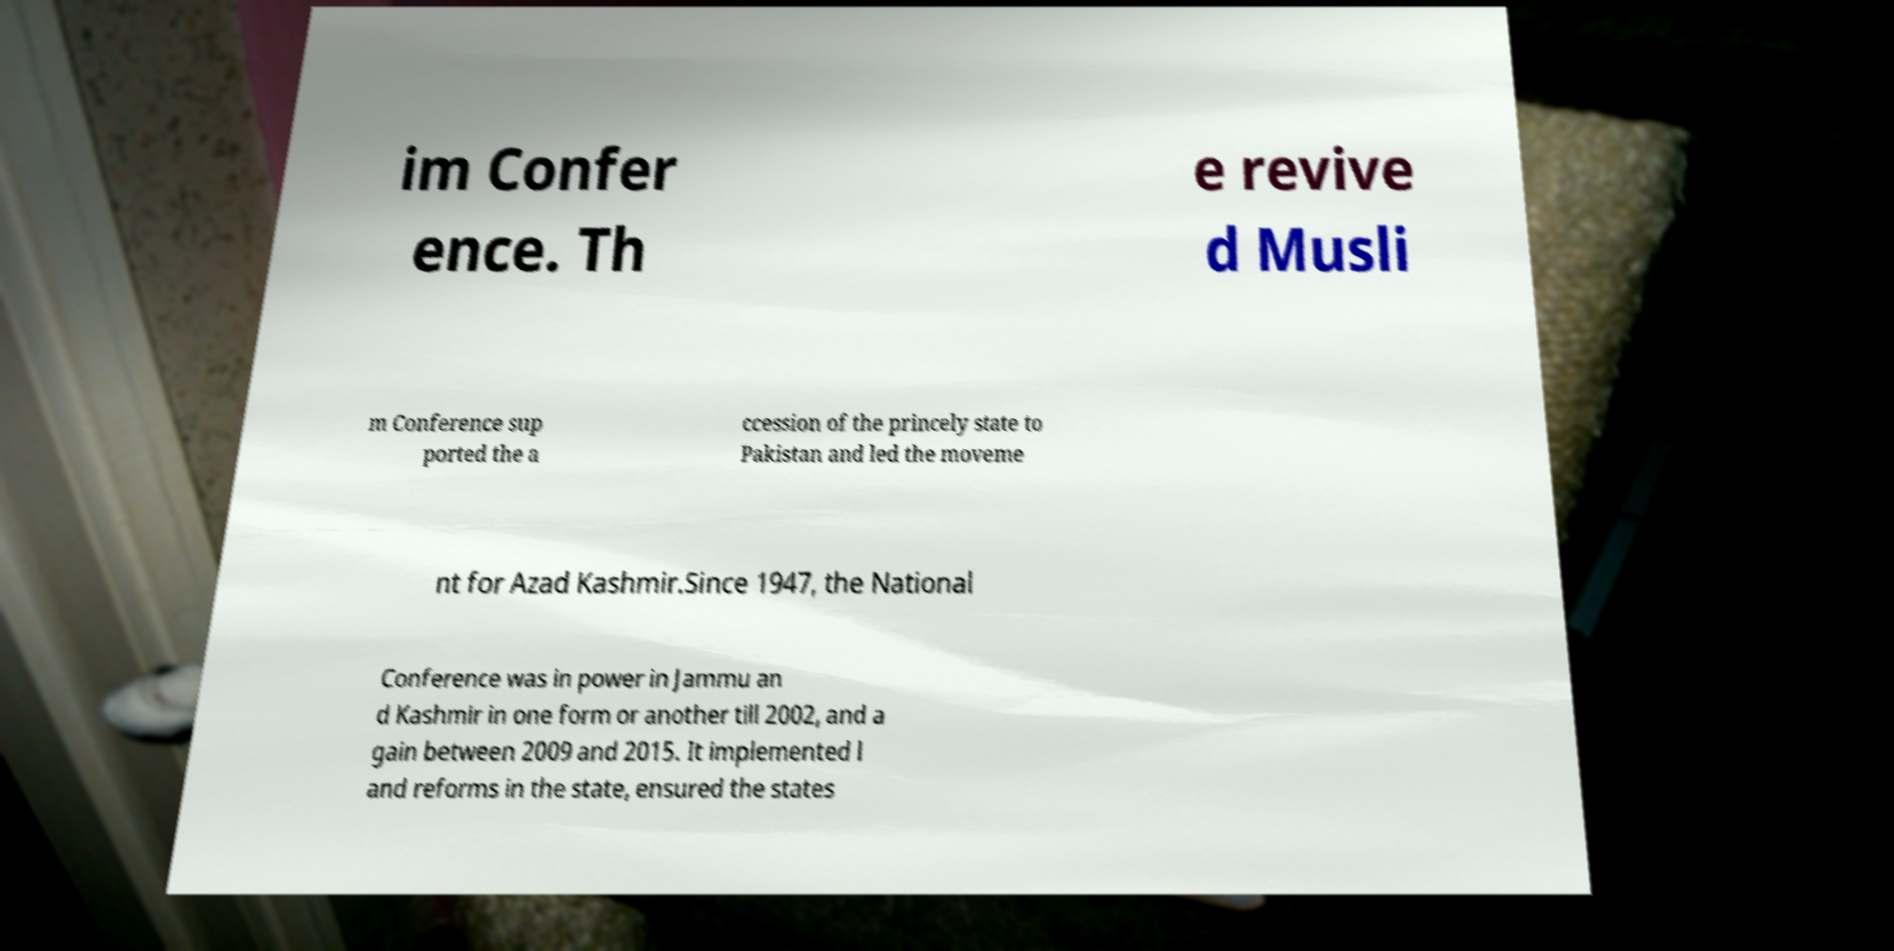There's text embedded in this image that I need extracted. Can you transcribe it verbatim? im Confer ence. Th e revive d Musli m Conference sup ported the a ccession of the princely state to Pakistan and led the moveme nt for Azad Kashmir.Since 1947, the National Conference was in power in Jammu an d Kashmir in one form or another till 2002, and a gain between 2009 and 2015. It implemented l and reforms in the state, ensured the states 